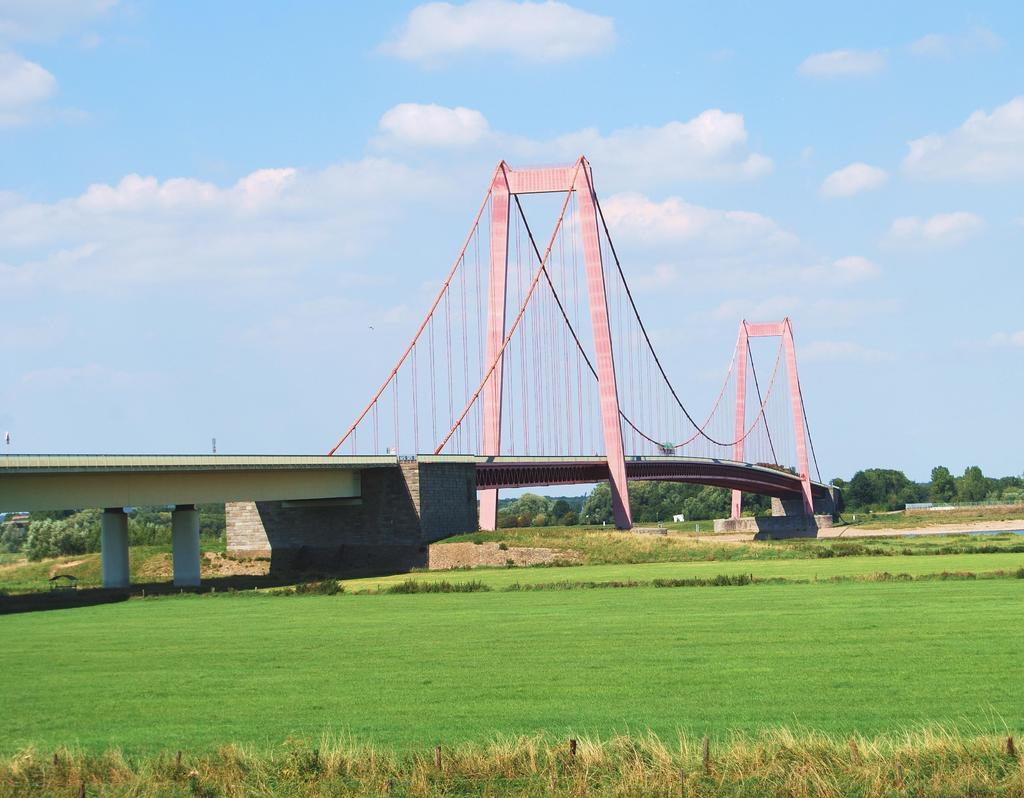What type of ground surface is visible in the image? There is grass on the ground in the image. What structures can be seen in the background of the image? There is a bridge, trees, and poles visible in the background of the image. What is visible in the sky in the background of the image? There are clouds visible in the sky in the background of the image. What type of hat is the grass wearing in the image? There is no hat present in the image, as the grass is a natural ground surface and not a person or object that could wear a hat. 